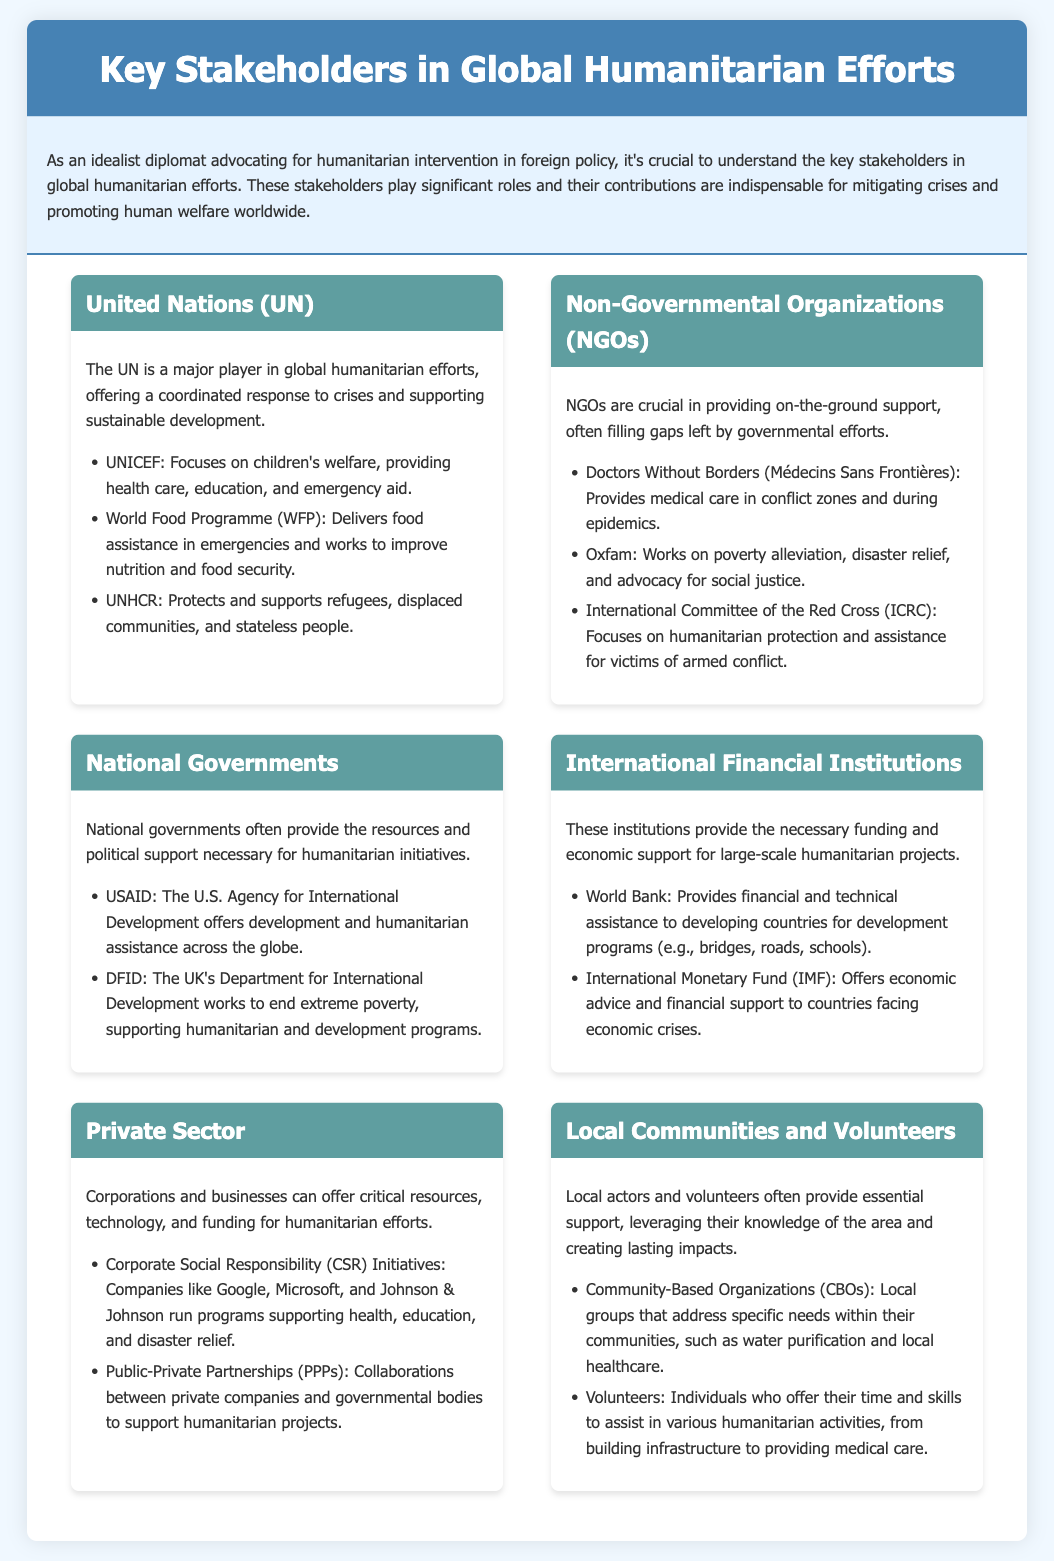What major player offers a coordinated response to crises? The document states that the UN is a major player in global humanitarian efforts, offering a coordinated response to crises.
Answer: UN Which organization focuses on children's welfare? According to the document, UNICEF is the organization that focuses on children's welfare, providing health care, education, and emergency aid.
Answer: UNICEF What does WFP stand for? The document mentions that WFP refers to the World Food Programme, which delivers food assistance in emergencies and works to improve nutrition and food security.
Answer: World Food Programme Which department works to end extreme poverty in the UK? The document states that DFID, which stands for the Department for International Development, works to end extreme poverty in the UK.
Answer: DFID What type of organizations often fill gaps left by governmental efforts? The document highlights that NGOs (Non-Governmental Organizations) are crucial in providing on-the-ground support and often fill gaps left by governmental efforts.
Answer: NGOs What does IMF provide? The document indicates that the International Monetary Fund (IMF) offers economic advice and financial support to countries facing economic crises.
Answer: Financial support Which major financial institution provides assistance for development programs? According to the document, the World Bank is the major financial institution that provides financial and technical assistance to developing countries for development programs.
Answer: World Bank What is a key role of local communities in humanitarian efforts? The document states that local communities and volunteers provide essential support, leveraging their knowledge of the area to create lasting impacts.
Answer: Essential support What term refers to collaborations between private companies and government bodies? The document refers to Public-Private Partnerships (PPPs) as collaborations between private companies and governmental bodies to support humanitarian projects.
Answer: Public-Private Partnerships 